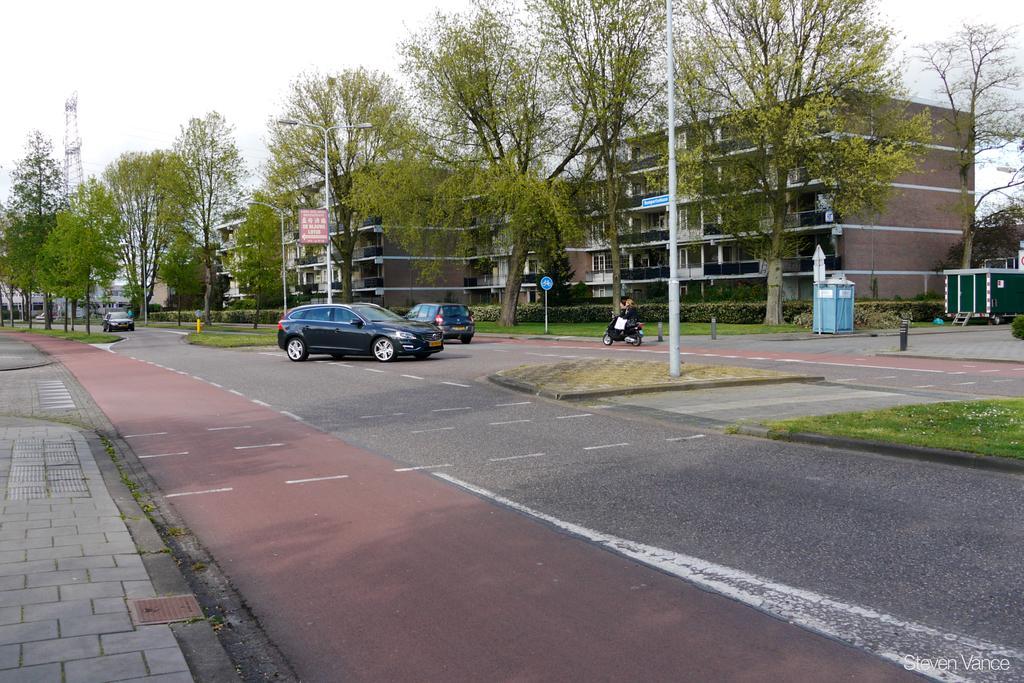Could you give a brief overview of what you see in this image? At the bottom of the image there is a road and we can see cars and a bike on the road. In the background there are trees, buildings and boards. We can see poles. At the top there is sky. 